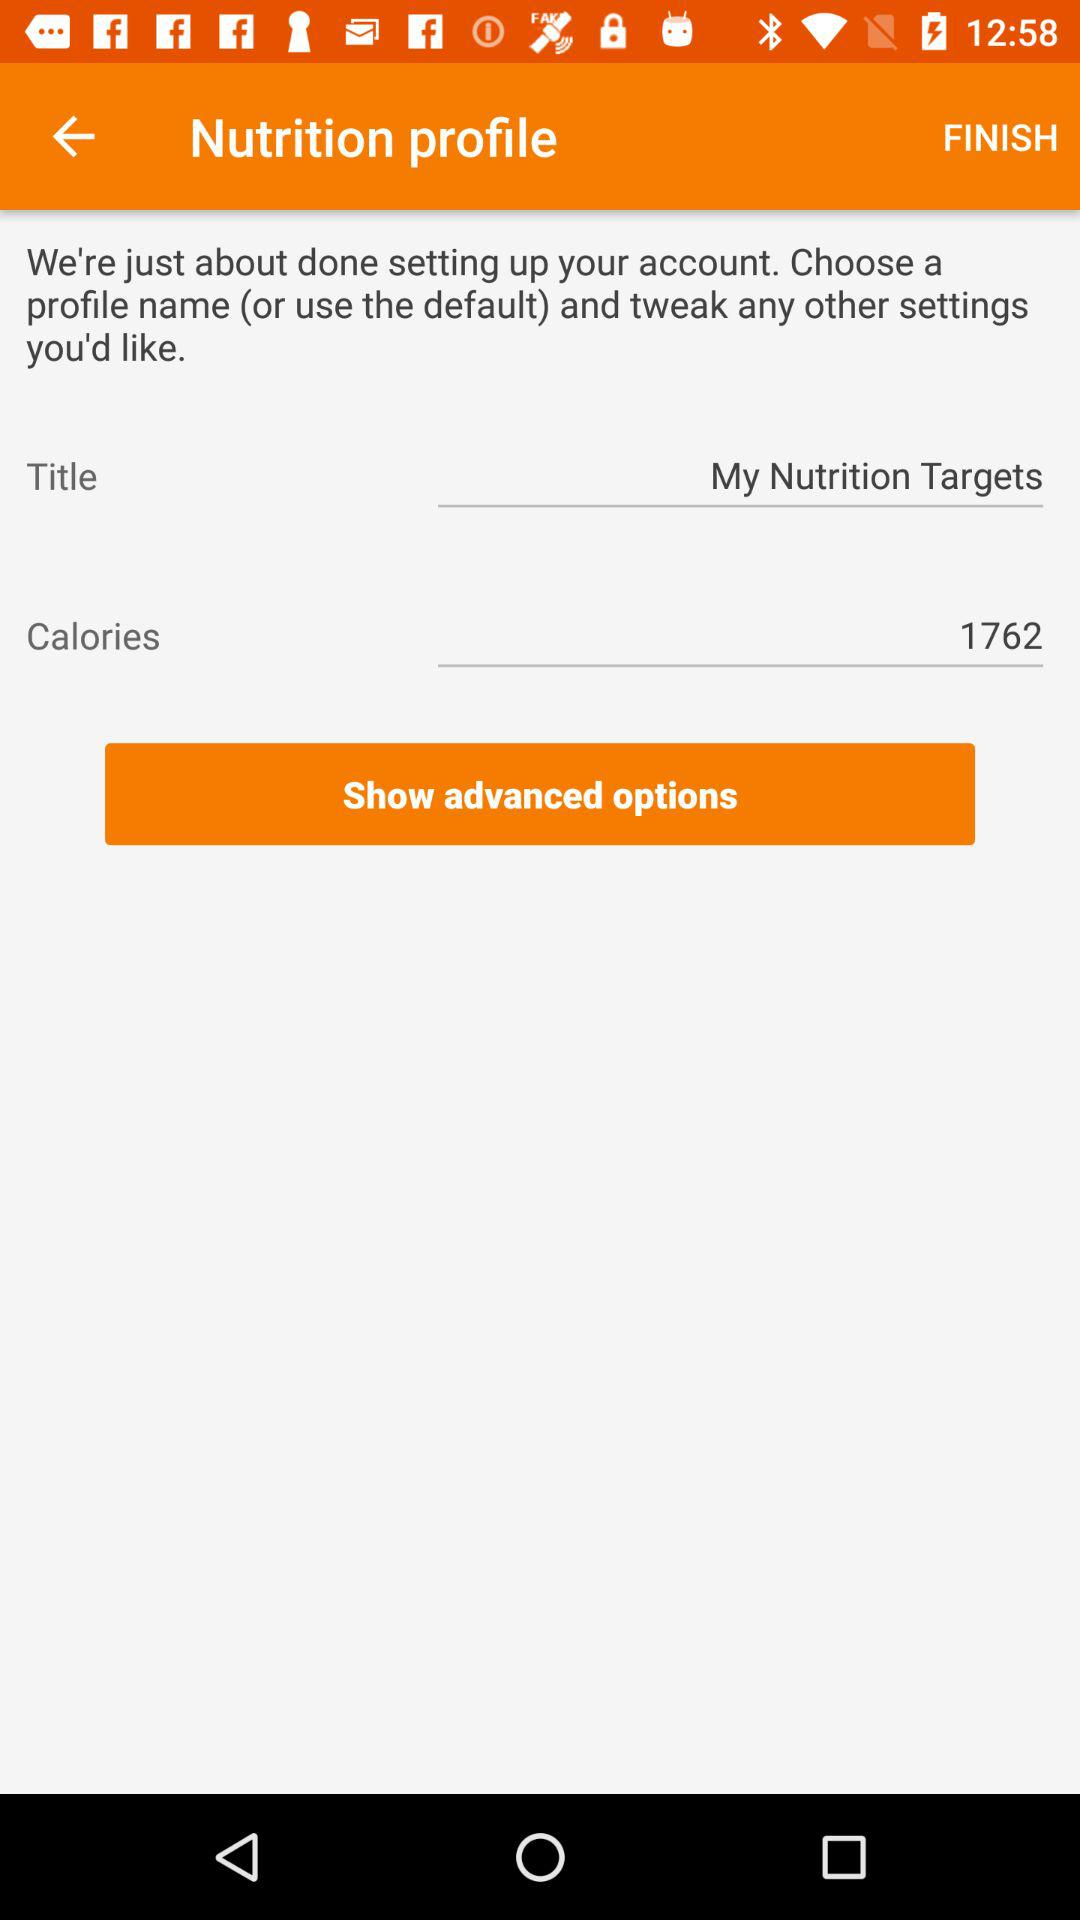What number is entered in the calories text field? The number is 1762. 